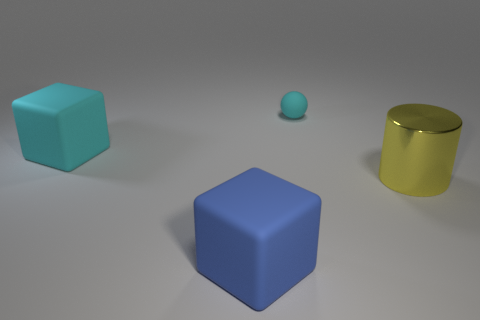Is there anything else that has the same material as the big yellow thing?
Offer a very short reply. No. There is a large block that is the same color as the matte ball; what is it made of?
Provide a short and direct response. Rubber. Are there any objects that have the same color as the matte ball?
Make the answer very short. Yes. Is there anything else that is the same size as the ball?
Your response must be concise. No. There is a cyan rubber thing that is on the right side of the cyan object that is on the left side of the cyan matte object right of the big cyan rubber block; how big is it?
Ensure brevity in your answer.  Small. Are the cyan block to the left of the blue matte cube and the big blue block made of the same material?
Your response must be concise. Yes. Is the number of small cyan objects less than the number of big matte objects?
Offer a very short reply. Yes. There is a large object in front of the big object that is on the right side of the small sphere; is there a large block that is behind it?
Ensure brevity in your answer.  Yes. There is a large matte object in front of the cyan rubber cube; is it the same shape as the tiny rubber thing?
Your answer should be compact. No. Is the number of things in front of the tiny cyan matte sphere greater than the number of cyan matte things?
Keep it short and to the point. Yes. 